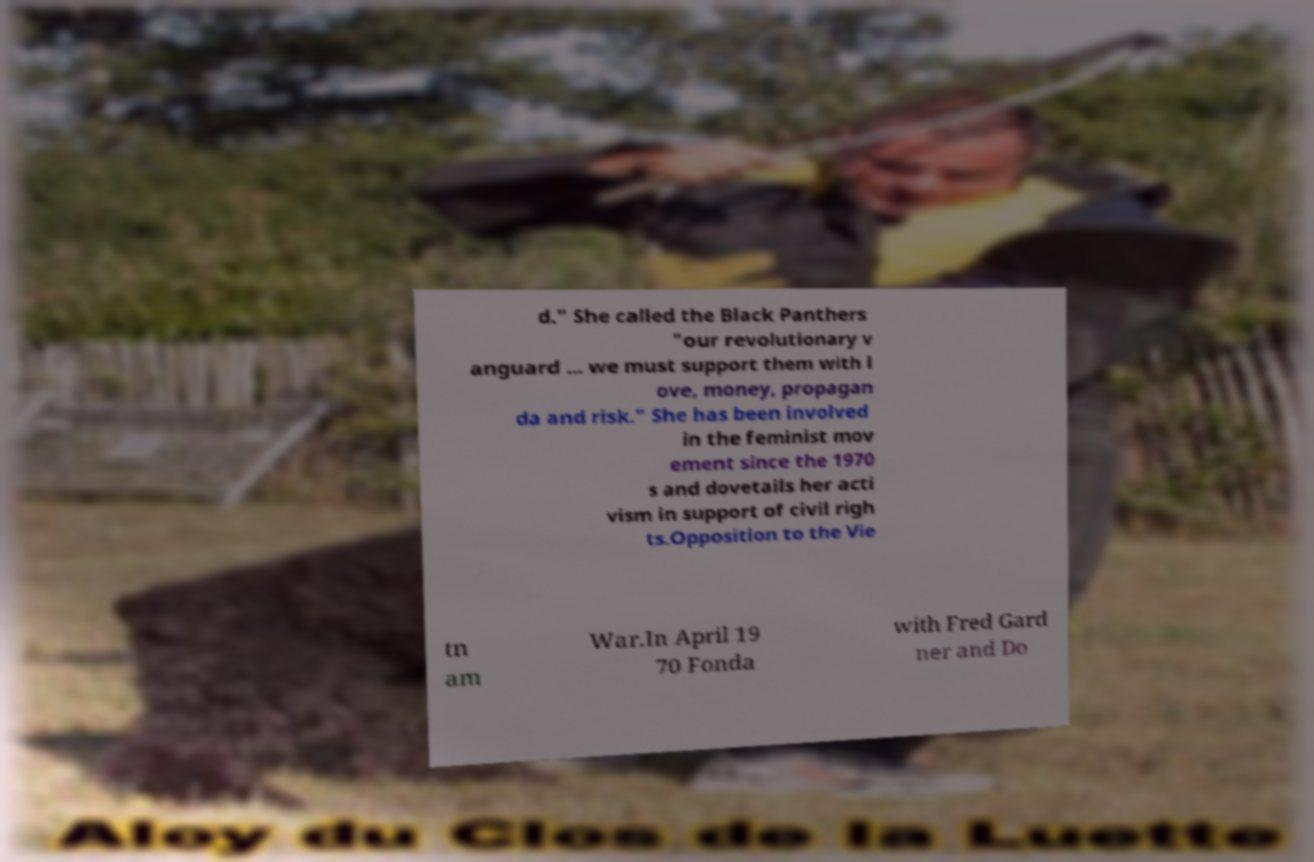For documentation purposes, I need the text within this image transcribed. Could you provide that? d." She called the Black Panthers "our revolutionary v anguard ... we must support them with l ove, money, propagan da and risk." She has been involved in the feminist mov ement since the 1970 s and dovetails her acti vism in support of civil righ ts.Opposition to the Vie tn am War.In April 19 70 Fonda with Fred Gard ner and Do 